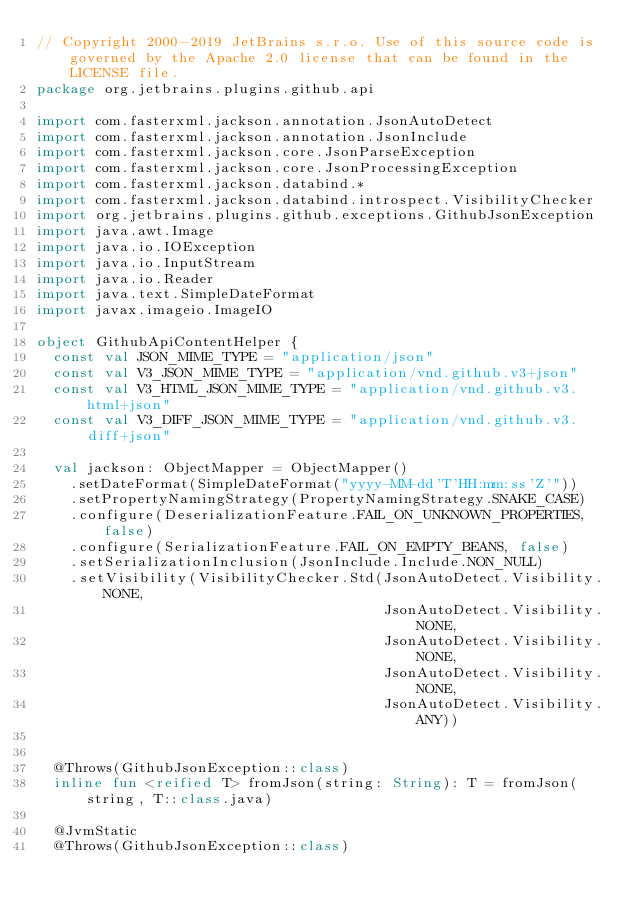<code> <loc_0><loc_0><loc_500><loc_500><_Kotlin_>// Copyright 2000-2019 JetBrains s.r.o. Use of this source code is governed by the Apache 2.0 license that can be found in the LICENSE file.
package org.jetbrains.plugins.github.api

import com.fasterxml.jackson.annotation.JsonAutoDetect
import com.fasterxml.jackson.annotation.JsonInclude
import com.fasterxml.jackson.core.JsonParseException
import com.fasterxml.jackson.core.JsonProcessingException
import com.fasterxml.jackson.databind.*
import com.fasterxml.jackson.databind.introspect.VisibilityChecker
import org.jetbrains.plugins.github.exceptions.GithubJsonException
import java.awt.Image
import java.io.IOException
import java.io.InputStream
import java.io.Reader
import java.text.SimpleDateFormat
import javax.imageio.ImageIO

object GithubApiContentHelper {
  const val JSON_MIME_TYPE = "application/json"
  const val V3_JSON_MIME_TYPE = "application/vnd.github.v3+json"
  const val V3_HTML_JSON_MIME_TYPE = "application/vnd.github.v3.html+json"
  const val V3_DIFF_JSON_MIME_TYPE = "application/vnd.github.v3.diff+json"

  val jackson: ObjectMapper = ObjectMapper()
    .setDateFormat(SimpleDateFormat("yyyy-MM-dd'T'HH:mm:ss'Z'"))
    .setPropertyNamingStrategy(PropertyNamingStrategy.SNAKE_CASE)
    .configure(DeserializationFeature.FAIL_ON_UNKNOWN_PROPERTIES, false)
    .configure(SerializationFeature.FAIL_ON_EMPTY_BEANS, false)
    .setSerializationInclusion(JsonInclude.Include.NON_NULL)
    .setVisibility(VisibilityChecker.Std(JsonAutoDetect.Visibility.NONE,
                                         JsonAutoDetect.Visibility.NONE,
                                         JsonAutoDetect.Visibility.NONE,
                                         JsonAutoDetect.Visibility.NONE,
                                         JsonAutoDetect.Visibility.ANY))


  @Throws(GithubJsonException::class)
  inline fun <reified T> fromJson(string: String): T = fromJson(string, T::class.java)

  @JvmStatic
  @Throws(GithubJsonException::class)</code> 